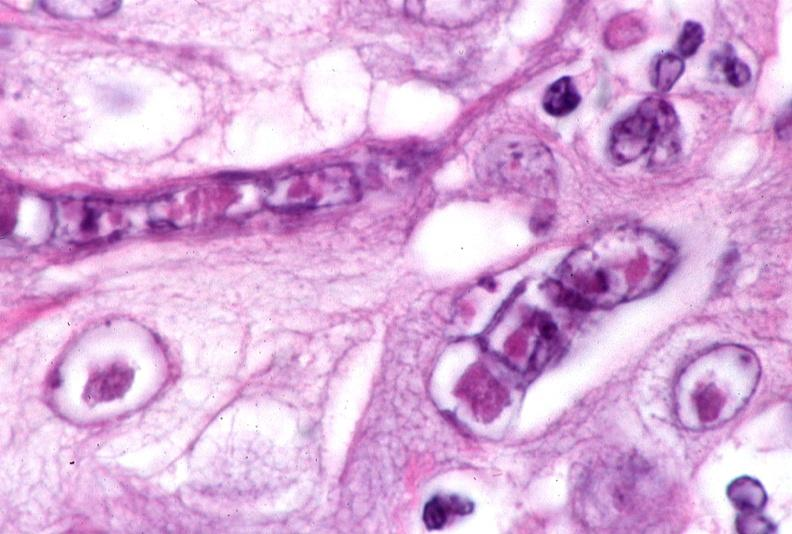what does this image show?
Answer the question using a single word or phrase. Skin 